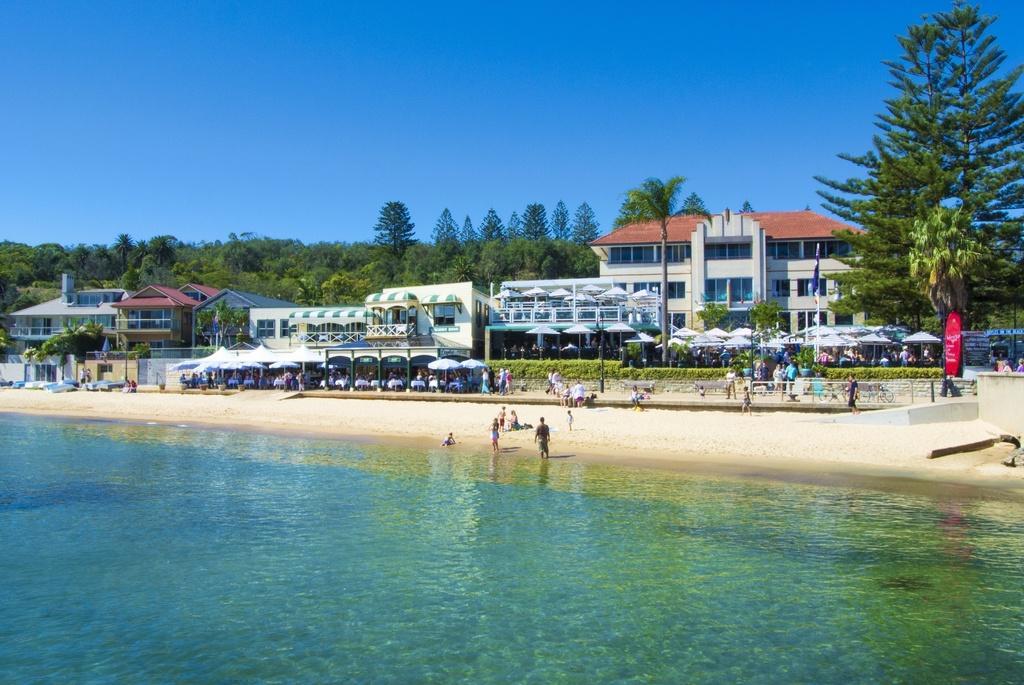How would you summarize this image in a sentence or two? At the bottom we can see water and there are few persons standing on the standing and few are sitting on a platform. In the background there are buildings,fences,hoardings,windows,roofs,poles,trees,tents,few persons and sky. 